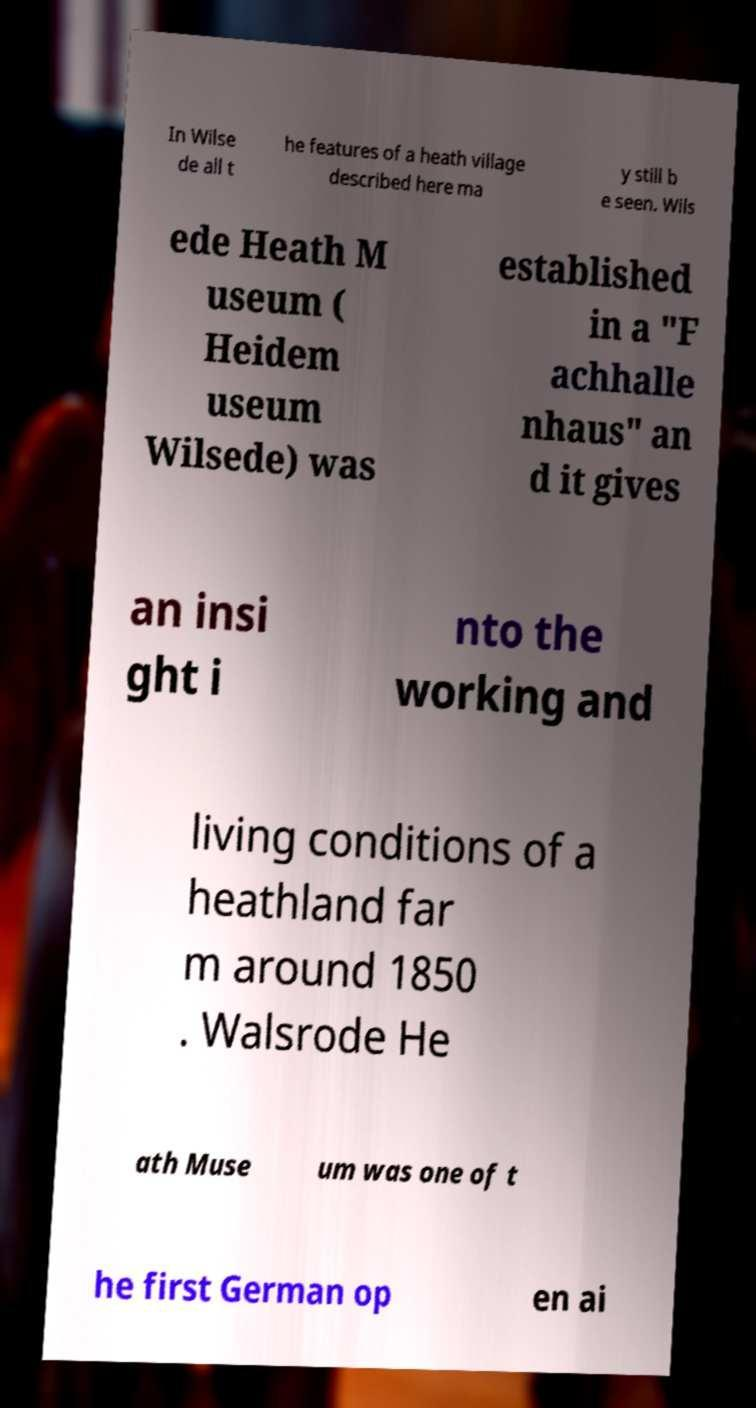Please identify and transcribe the text found in this image. In Wilse de all t he features of a heath village described here ma y still b e seen. Wils ede Heath M useum ( Heidem useum Wilsede) was established in a "F achhalle nhaus" an d it gives an insi ght i nto the working and living conditions of a heathland far m around 1850 . Walsrode He ath Muse um was one of t he first German op en ai 